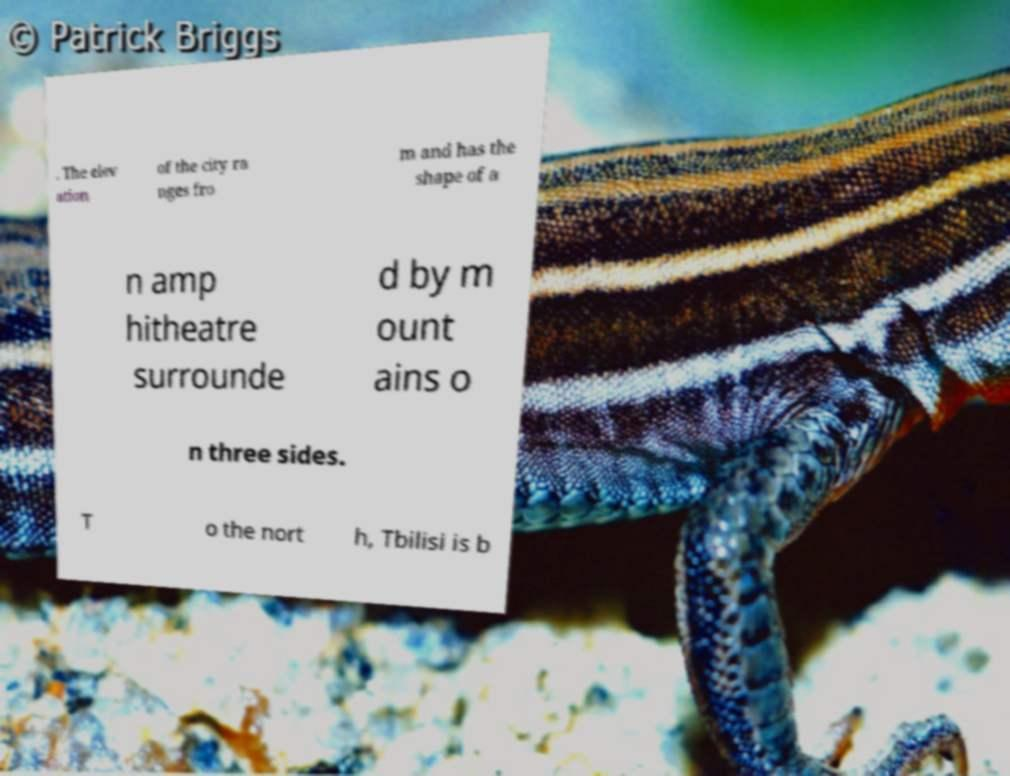Can you accurately transcribe the text from the provided image for me? . The elev ation of the city ra nges fro m and has the shape of a n amp hitheatre surrounde d by m ount ains o n three sides. T o the nort h, Tbilisi is b 